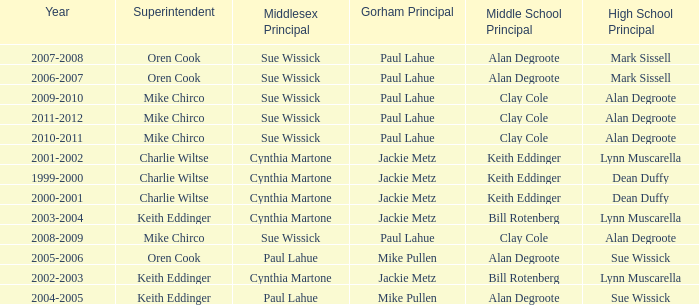Could you help me parse every detail presented in this table? {'header': ['Year', 'Superintendent', 'Middlesex Principal', 'Gorham Principal', 'Middle School Principal', 'High School Principal'], 'rows': [['2007-2008', 'Oren Cook', 'Sue Wissick', 'Paul Lahue', 'Alan Degroote', 'Mark Sissell'], ['2006-2007', 'Oren Cook', 'Sue Wissick', 'Paul Lahue', 'Alan Degroote', 'Mark Sissell'], ['2009-2010', 'Mike Chirco', 'Sue Wissick', 'Paul Lahue', 'Clay Cole', 'Alan Degroote'], ['2011-2012', 'Mike Chirco', 'Sue Wissick', 'Paul Lahue', 'Clay Cole', 'Alan Degroote'], ['2010-2011', 'Mike Chirco', 'Sue Wissick', 'Paul Lahue', 'Clay Cole', 'Alan Degroote'], ['2001-2002', 'Charlie Wiltse', 'Cynthia Martone', 'Jackie Metz', 'Keith Eddinger', 'Lynn Muscarella'], ['1999-2000', 'Charlie Wiltse', 'Cynthia Martone', 'Jackie Metz', 'Keith Eddinger', 'Dean Duffy'], ['2000-2001', 'Charlie Wiltse', 'Cynthia Martone', 'Jackie Metz', 'Keith Eddinger', 'Dean Duffy'], ['2003-2004', 'Keith Eddinger', 'Cynthia Martone', 'Jackie Metz', 'Bill Rotenberg', 'Lynn Muscarella'], ['2008-2009', 'Mike Chirco', 'Sue Wissick', 'Paul Lahue', 'Clay Cole', 'Alan Degroote'], ['2005-2006', 'Oren Cook', 'Paul Lahue', 'Mike Pullen', 'Alan Degroote', 'Sue Wissick'], ['2002-2003', 'Keith Eddinger', 'Cynthia Martone', 'Jackie Metz', 'Bill Rotenberg', 'Lynn Muscarella'], ['2004-2005', 'Keith Eddinger', 'Paul Lahue', 'Mike Pullen', 'Alan Degroote', 'Sue Wissick']]} Who were the superintendent(s) when the middle school principal was alan degroote, the gorham principal was paul lahue, and the year was 2006-2007? Oren Cook. 